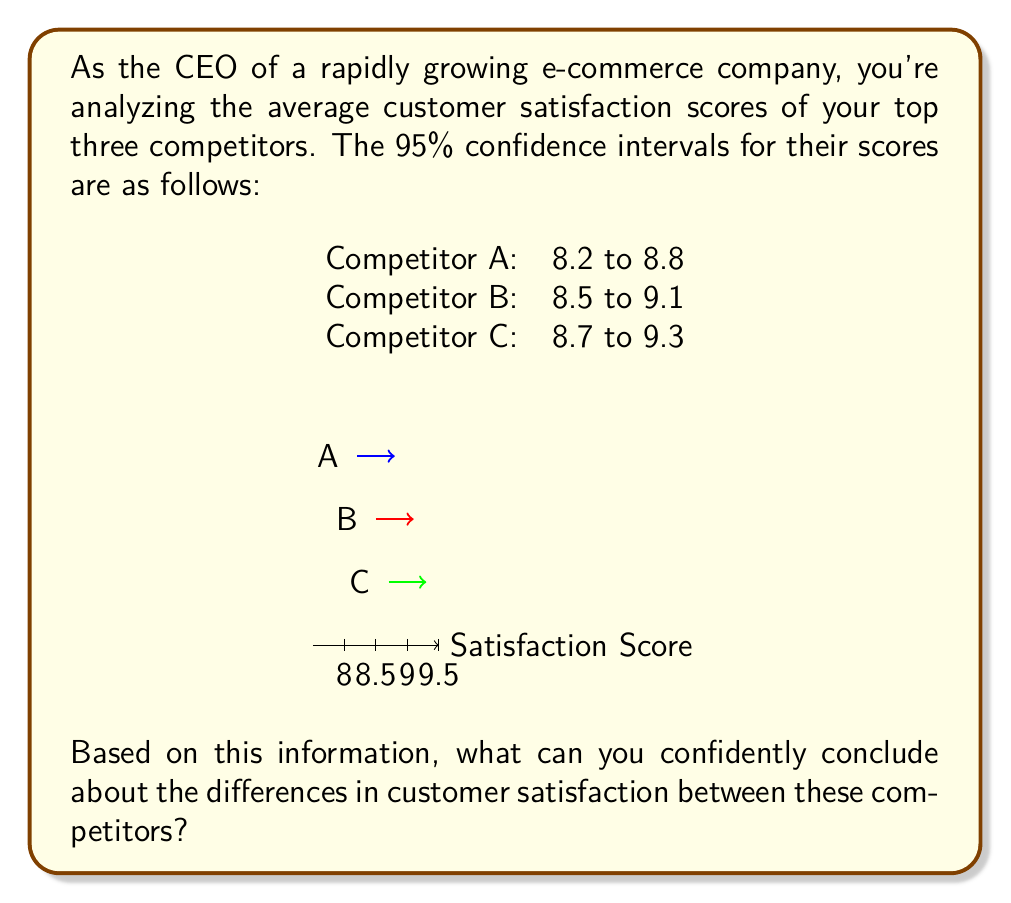Teach me how to tackle this problem. To interpret overlapping confidence intervals, we need to follow these steps:

1. Understand the meaning of confidence intervals:
   A 95% confidence interval means we can be 95% confident that the true population mean falls within this range.

2. Examine the overlap:
   - A and B overlap from 8.5 to 8.8
   - B and C overlap from 8.7 to 9.1
   - A and C do not overlap

3. Interpret the overlaps:
   - When confidence intervals overlap, we cannot conclude that there is a statistically significant difference between the means at the 95% confidence level.
   - When confidence intervals do not overlap, we can conclude that there is a statistically significant difference between the means at the 95% confidence level.

4. Apply this interpretation to our data:
   - We cannot conclude there's a significant difference between A and B, or between B and C.
   - We can conclude there's a significant difference between A and C.

5. Formulate the conclusion:
   The only statistically significant difference we can confidently assert is between Competitor A and Competitor C, with C having a higher customer satisfaction score than A.

It's important to note that overlapping confidence intervals don't necessarily mean there is no difference, just that we can't be confident about the difference at this level of certainty. Further statistical tests might reveal differences that aren't apparent from confidence intervals alone.
Answer: Competitor C has significantly higher customer satisfaction than Competitor A; no other differences can be confidently concluded. 